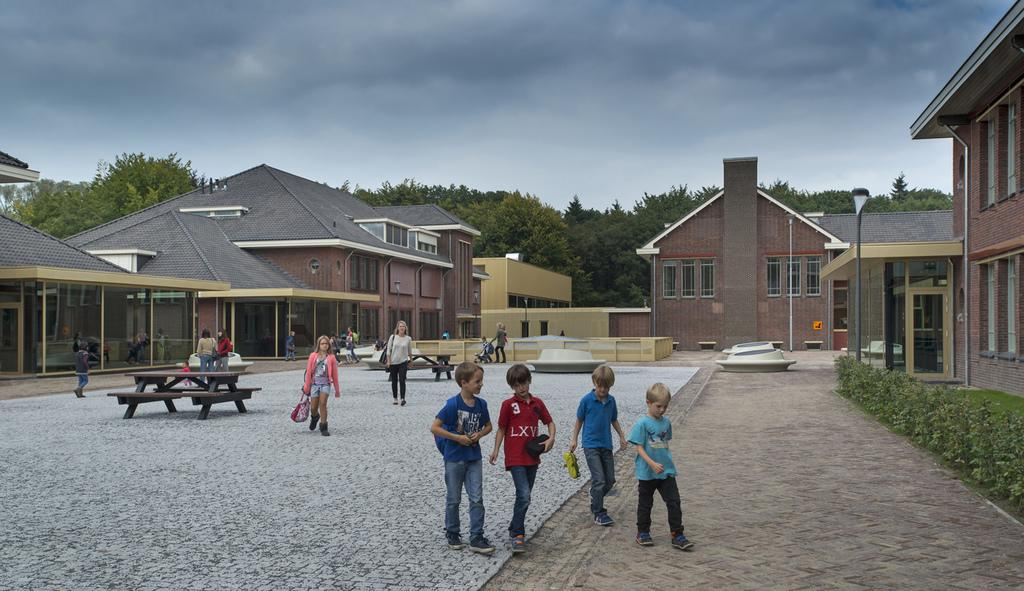How many people can be seen in the image? There are many kids in the image. Can you describe the people in the image? There are women in the image as well. What are the people in the image doing? The people are walking on the floor. What type of structures are visible in the image? There are homes in the image. How are the homes situated in the image? The homes are surrounded by land. What can be seen behind the homes? There are trees behind the homes. What is visible in the sky in the image? The sky is visible in the image, and clouds are present. What type of quiver is being used by the grandfather in the image? There is no grandfather or quiver present in the image. What instrument is being played by the kids in the image? The image does not mention any instruments being played by the kids in the image. 